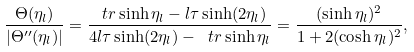Convert formula to latex. <formula><loc_0><loc_0><loc_500><loc_500>\frac { \Theta ( \eta _ { l } ) } { | \Theta ^ { \prime \prime } ( \eta _ { l } ) | } = \frac { \ t r \sinh \eta _ { l } - l \tau \sinh ( 2 \eta _ { l } ) } { 4 l \tau \sinh ( 2 \eta _ { l } ) - \ t r \sinh \eta _ { l } } = \frac { ( \sinh \eta _ { l } ) ^ { 2 } } { 1 + 2 ( \cosh \eta _ { l } ) ^ { 2 } } ,</formula> 